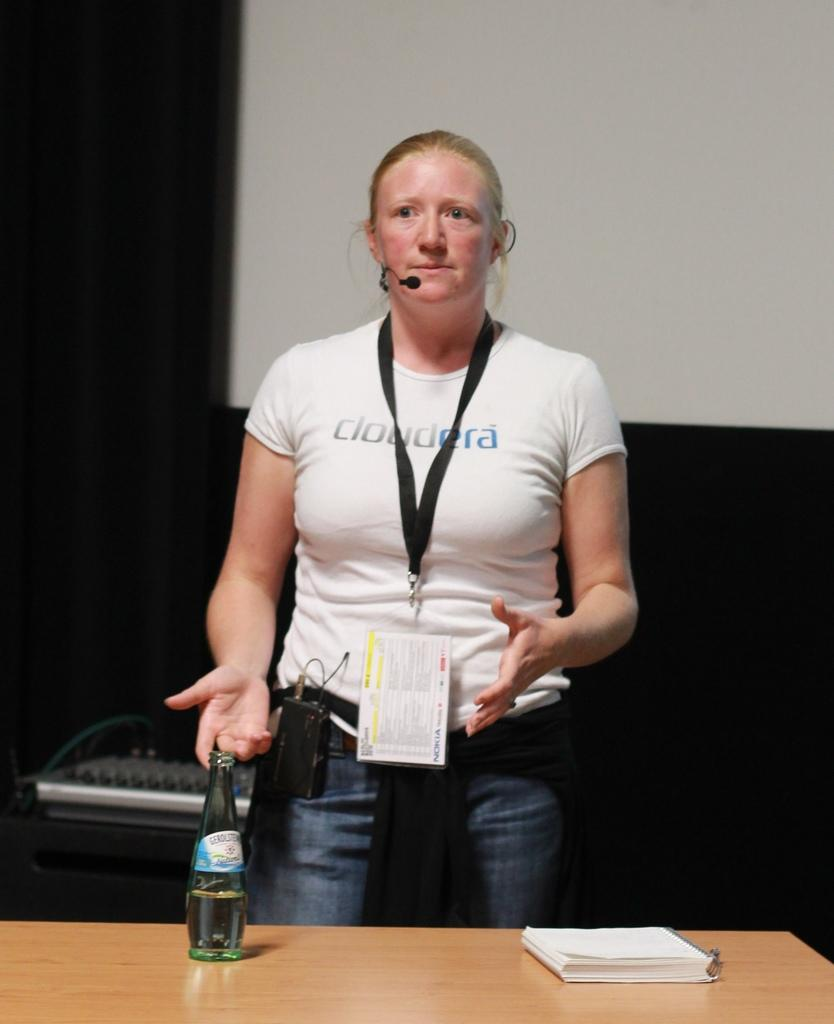Who is the main subject in the image? There is a woman in the image. What is the woman doing in the image? The woman is standing in front of a table and speaking into a microphone. What objects are on the table in the image? There is a book and a bottle on the table in the image. What is the woman holding in the image? The woman is holding a microphone. What type of development can be seen in the garden behind the woman in the image? There is no garden or development visible in the image. 